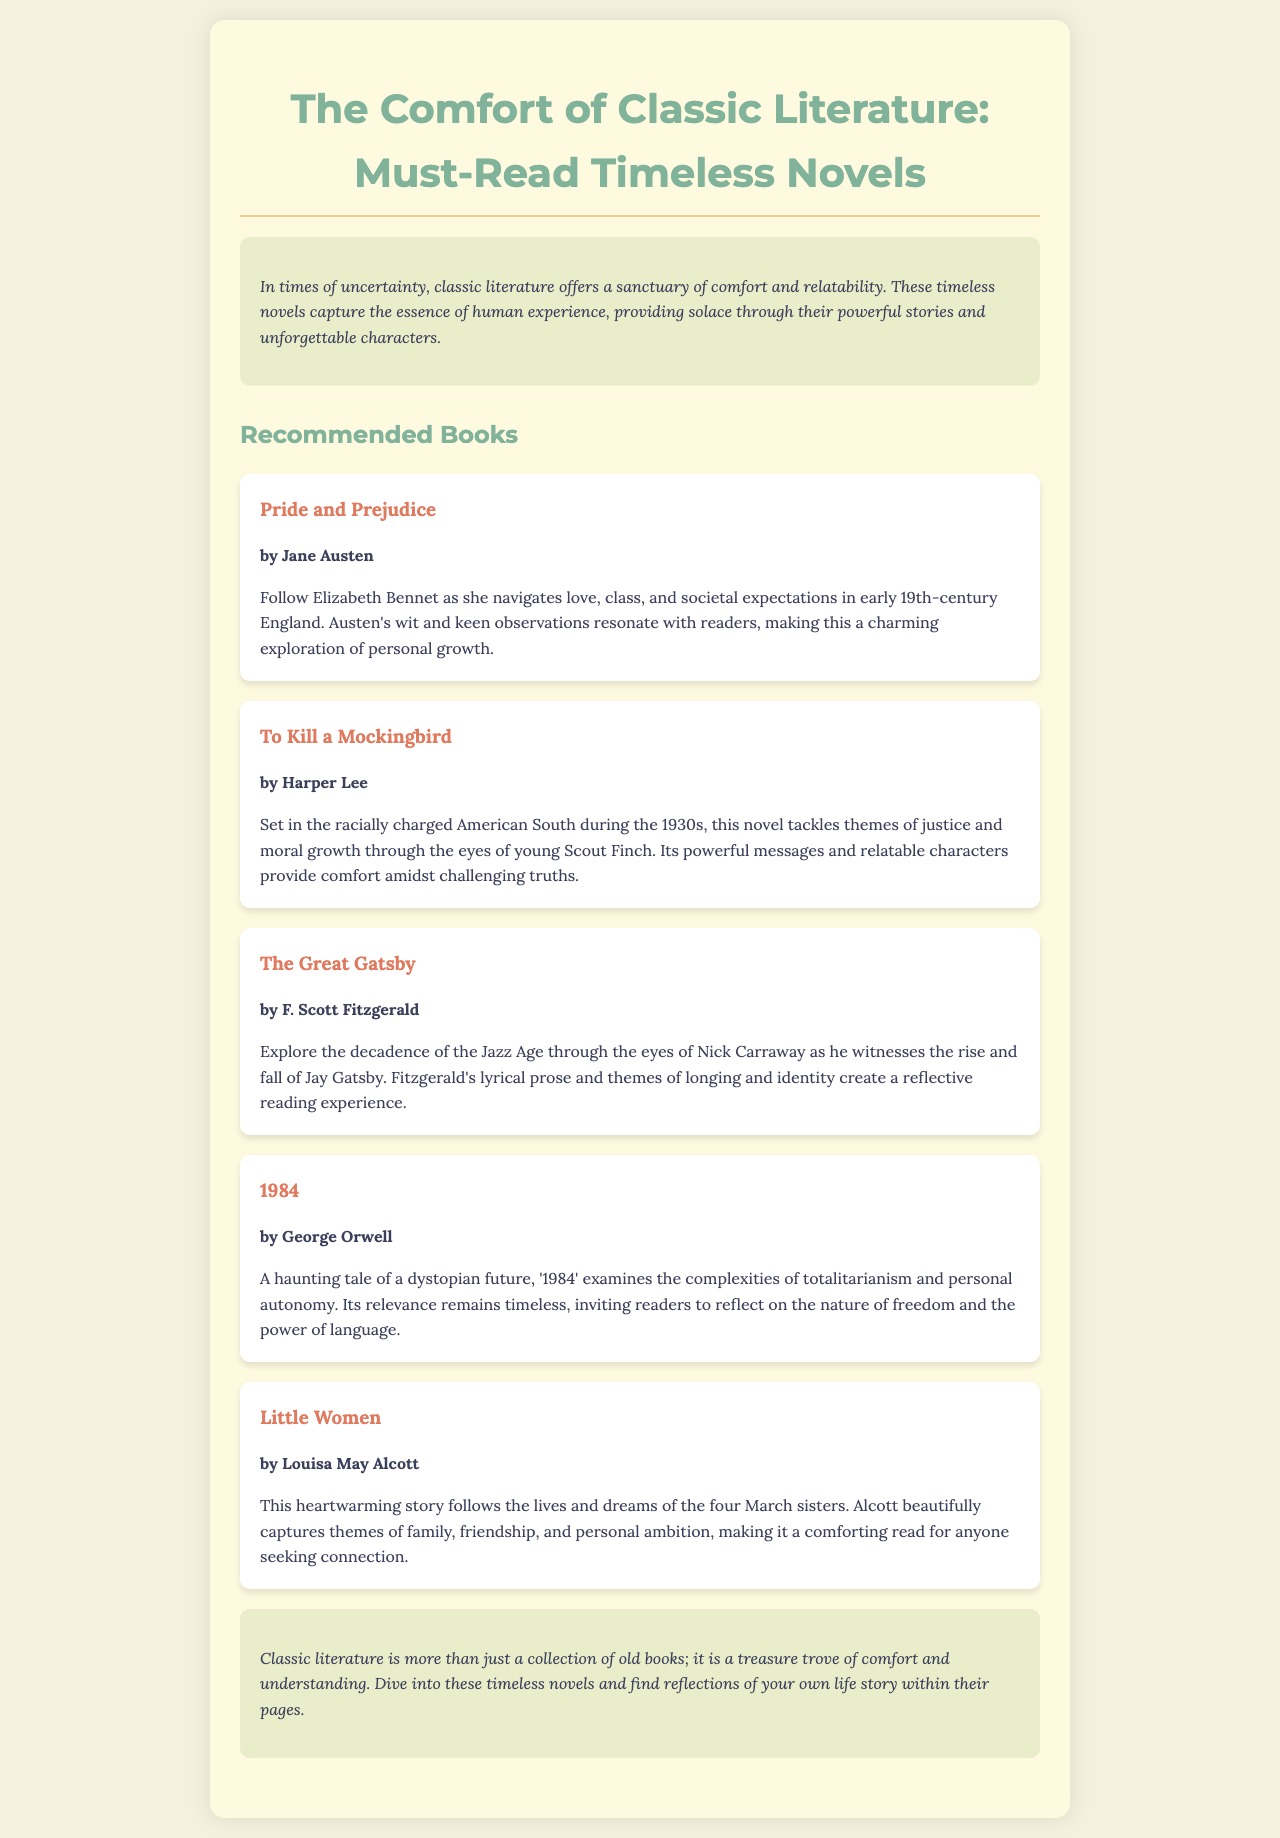What is the title of the brochure? The title is presented prominently at the top of the document.
Answer: The Comfort of Classic Literature: Must-Read Timeless Novels Who is the author of "Pride and Prejudice"? The author is mentioned in the book section of the document.
Answer: Jane Austen What year does "To Kill a Mockingbird" take place? The document specifies the decade in which the story is set.
Answer: 1930s Which author wrote "1984"? The author is listed below the book title in the document.
Answer: George Orwell What central theme does "Little Women" focus on? The document discusses the themes of the book.
Answer: Family, friendship, and personal ambition How many books are recommended in the brochure? The total count can be obtained by reviewing the number of book entries in the document.
Answer: Five What type of literature does the brochure discuss? The brochure categorizes its content under a specific literary genre.
Answer: Classic literature What does the introduction suggest about classic literature? The introduction includes a summary of the benefits or feelings associated with classic literature.
Answer: Comfort and relatability What is described as the setting of "The Great Gatsby"? The document describes the backdrop of the story.
Answer: The Jazz Age 